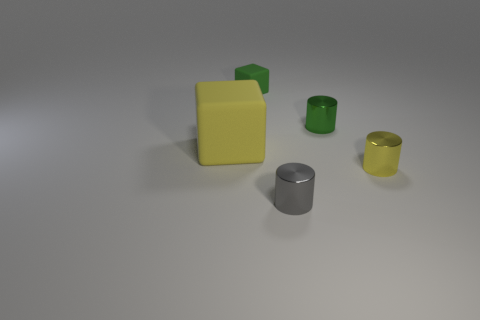Subtract all tiny green shiny cylinders. How many cylinders are left? 2 Add 5 large brown metallic blocks. How many objects exist? 10 Subtract all green cylinders. How many cylinders are left? 2 Subtract all cylinders. How many objects are left? 2 Subtract 0 cyan cylinders. How many objects are left? 5 Subtract 1 blocks. How many blocks are left? 1 Subtract all green cubes. Subtract all brown spheres. How many cubes are left? 1 Subtract all green balls. How many red cylinders are left? 0 Subtract all big blue cylinders. Subtract all large yellow objects. How many objects are left? 4 Add 5 yellow metallic cylinders. How many yellow metallic cylinders are left? 6 